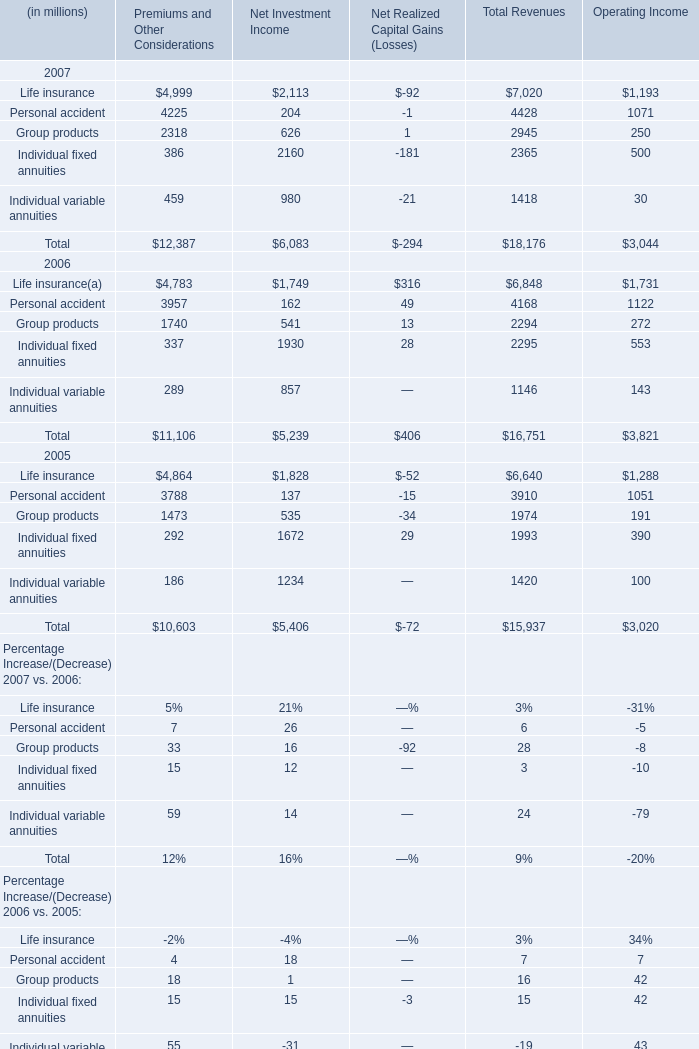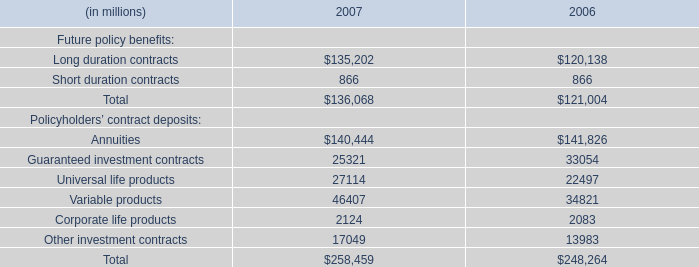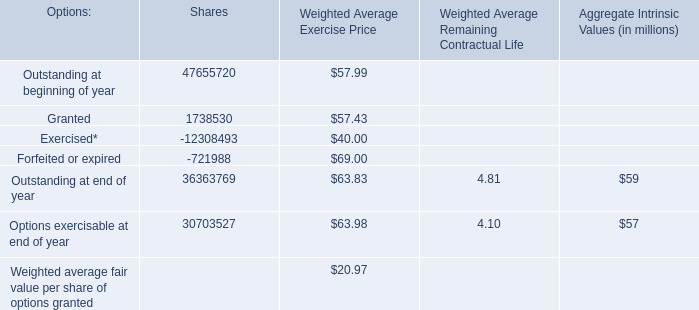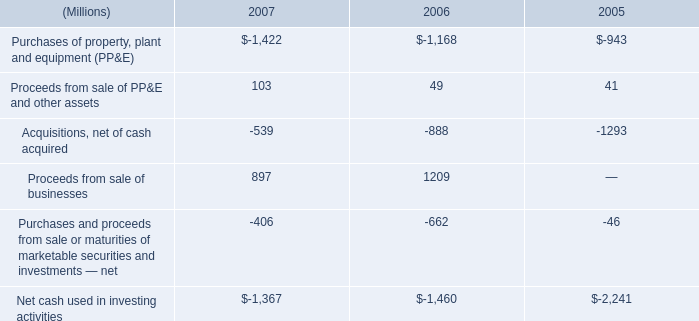in 2006 what was the ratio of the increase in tax payments in 2005 and 2006 to the decrease in cash 
Computations: (600 / 365)
Answer: 1.64384. 